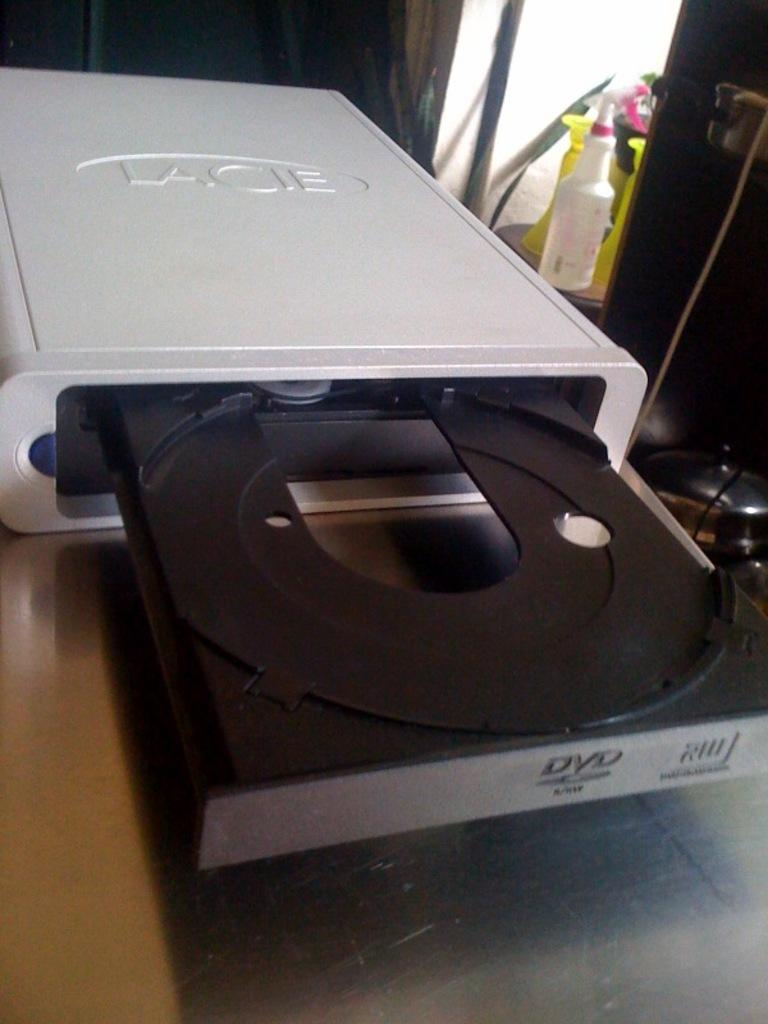<image>
Offer a succinct explanation of the picture presented. A white DVD drive with the brand Lacie written on the top. 